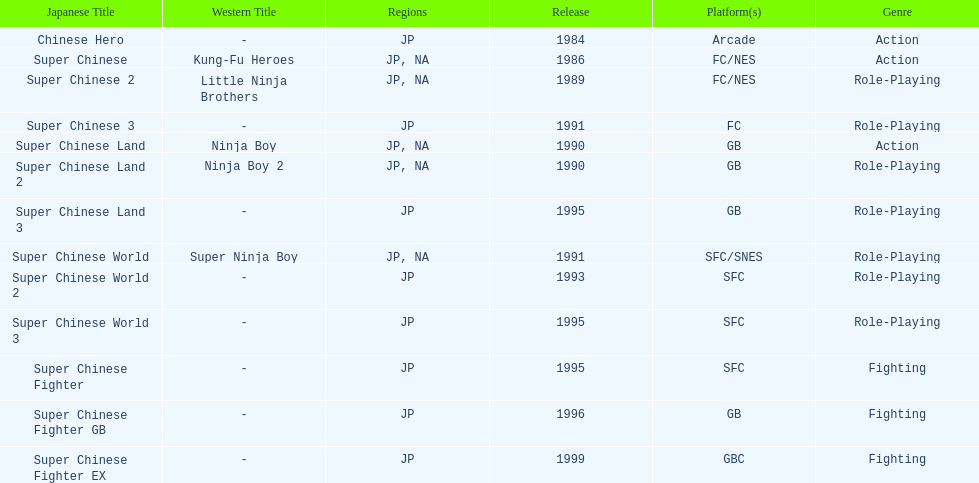What's the overall count of super chinese games that have been launched? 13. 